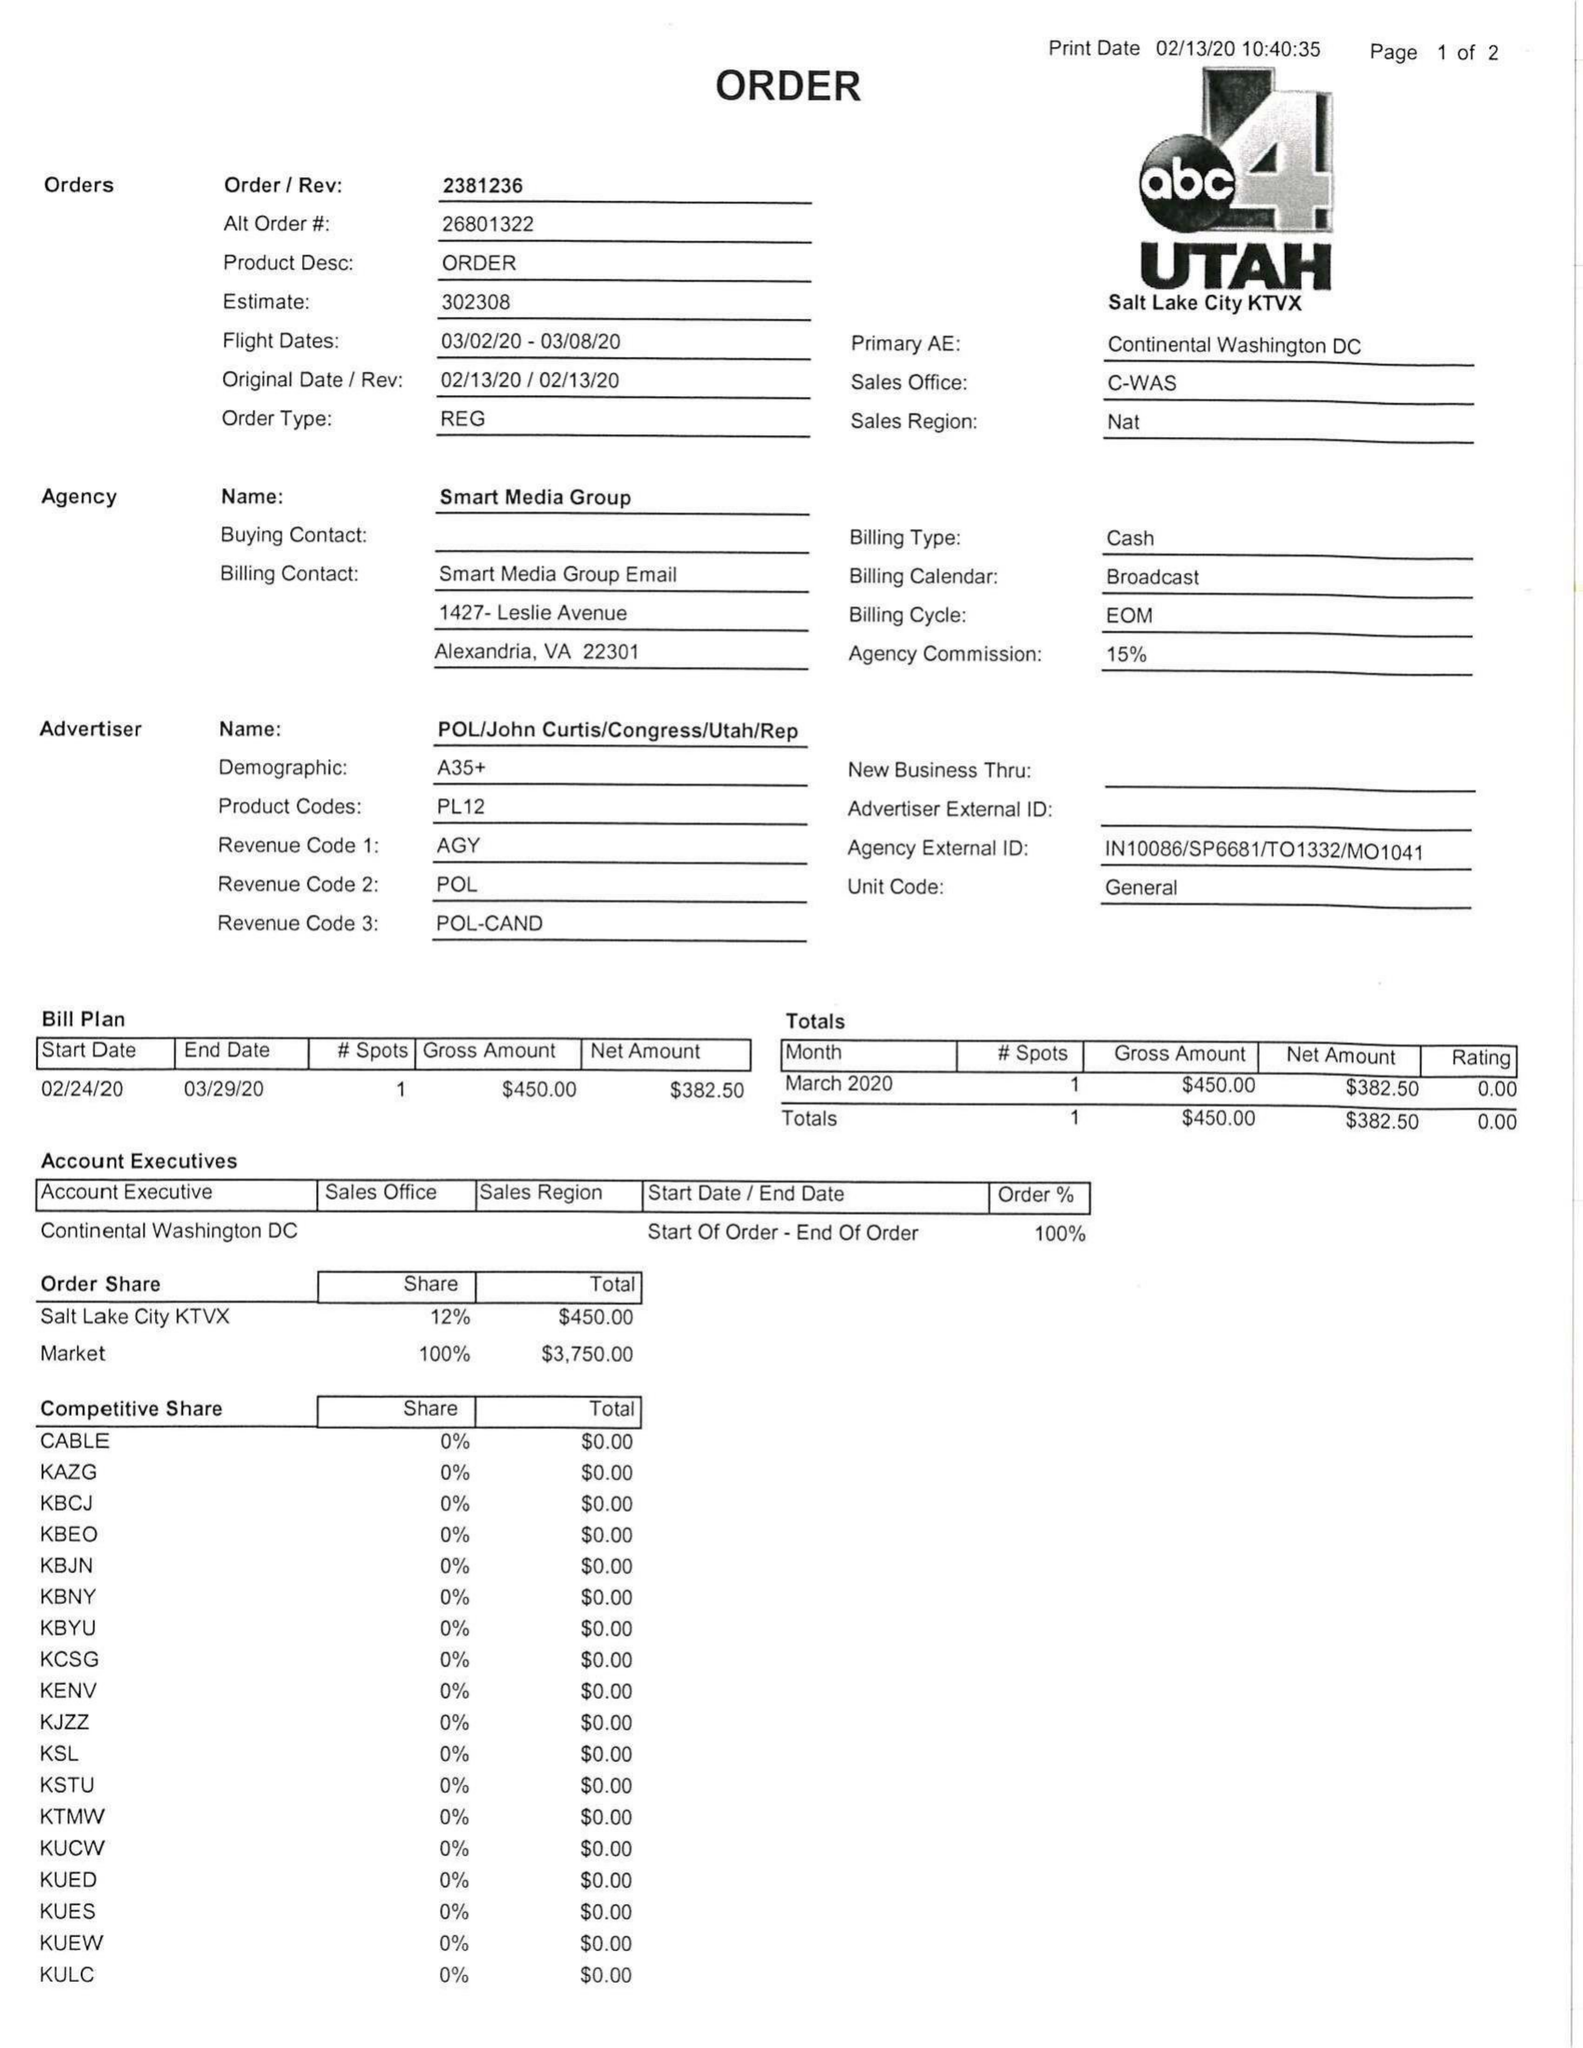What is the value for the advertiser?
Answer the question using a single word or phrase. POL/JOHNCURTIS/CONGRESS/UTAH/REP 